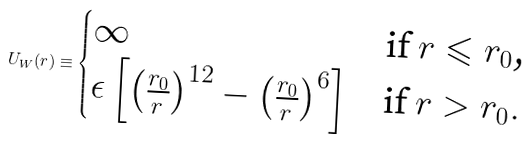Convert formula to latex. <formula><loc_0><loc_0><loc_500><loc_500>U _ { W } ( r ) \equiv \begin{cases} \infty & \text {if $r\leqslant r_{0}$,} \\ \epsilon \left [ \left ( \frac { r _ { 0 } } { r } \right ) ^ { 1 2 } - \left ( \frac { r _ { 0 } } { r } \right ) ^ { 6 } \right ] & \text {if $r>r_{0}$} . \\ \end{cases}</formula> 